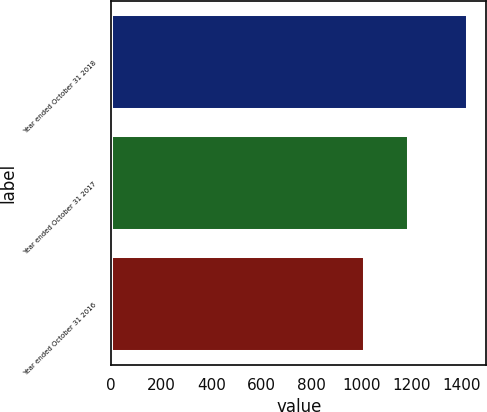Convert chart. <chart><loc_0><loc_0><loc_500><loc_500><bar_chart><fcel>Year ended October 31 2018<fcel>Year ended October 31 2017<fcel>Year ended October 31 2016<nl><fcel>1428<fcel>1189<fcel>1014<nl></chart> 